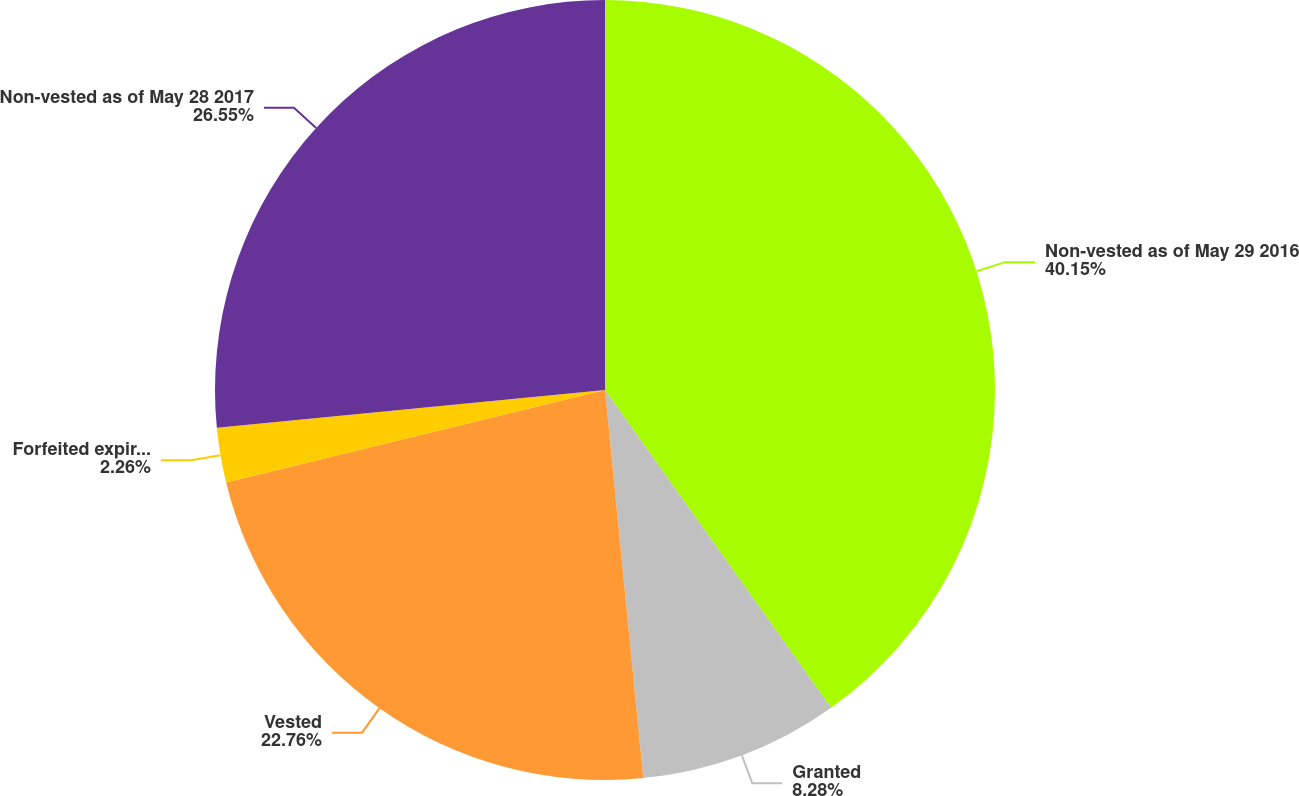Convert chart to OTSL. <chart><loc_0><loc_0><loc_500><loc_500><pie_chart><fcel>Non-vested as of May 29 2016<fcel>Granted<fcel>Vested<fcel>Forfeited expired or<fcel>Non-vested as of May 28 2017<nl><fcel>40.16%<fcel>8.28%<fcel>22.76%<fcel>2.26%<fcel>26.55%<nl></chart> 